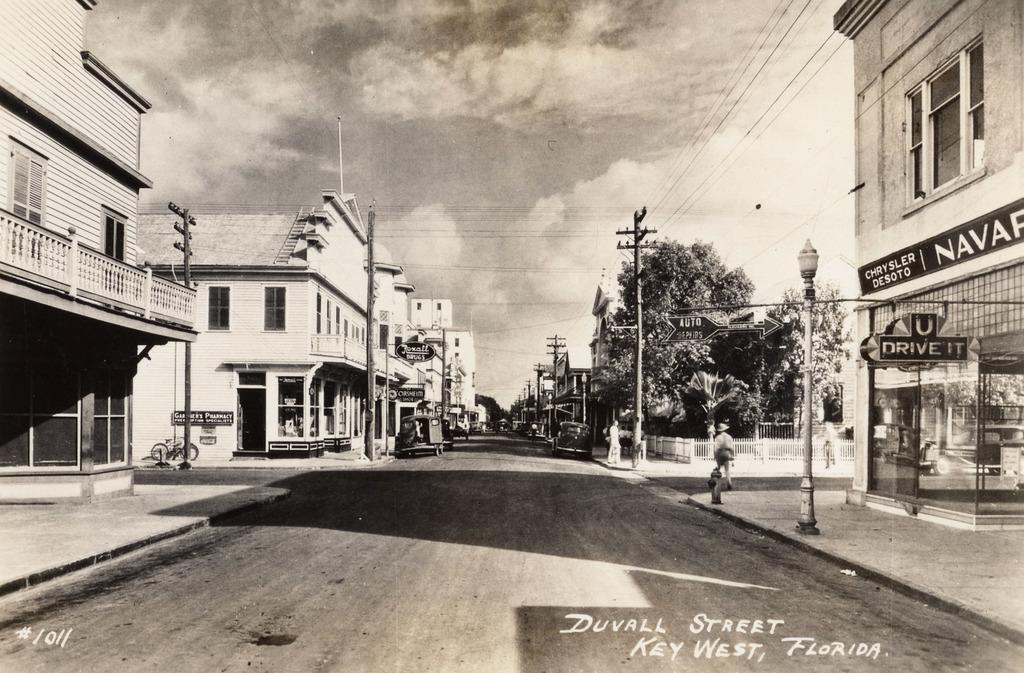Could you give a brief overview of what you see in this image? In this picture I can see vehicles on the road, there are group of people, buildings, poles, lights, boards, trees, fence, cables, and in the background there is sky and there are watermarks on the image. 